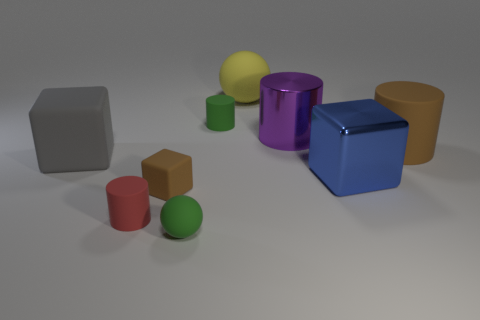Add 1 red cylinders. How many objects exist? 10 Subtract all red cylinders. Subtract all gray blocks. How many cylinders are left? 3 Subtract all cylinders. How many objects are left? 5 Add 9 big matte balls. How many big matte balls are left? 10 Add 1 large gray blocks. How many large gray blocks exist? 2 Subtract 0 gray spheres. How many objects are left? 9 Subtract all large matte blocks. Subtract all large green matte things. How many objects are left? 8 